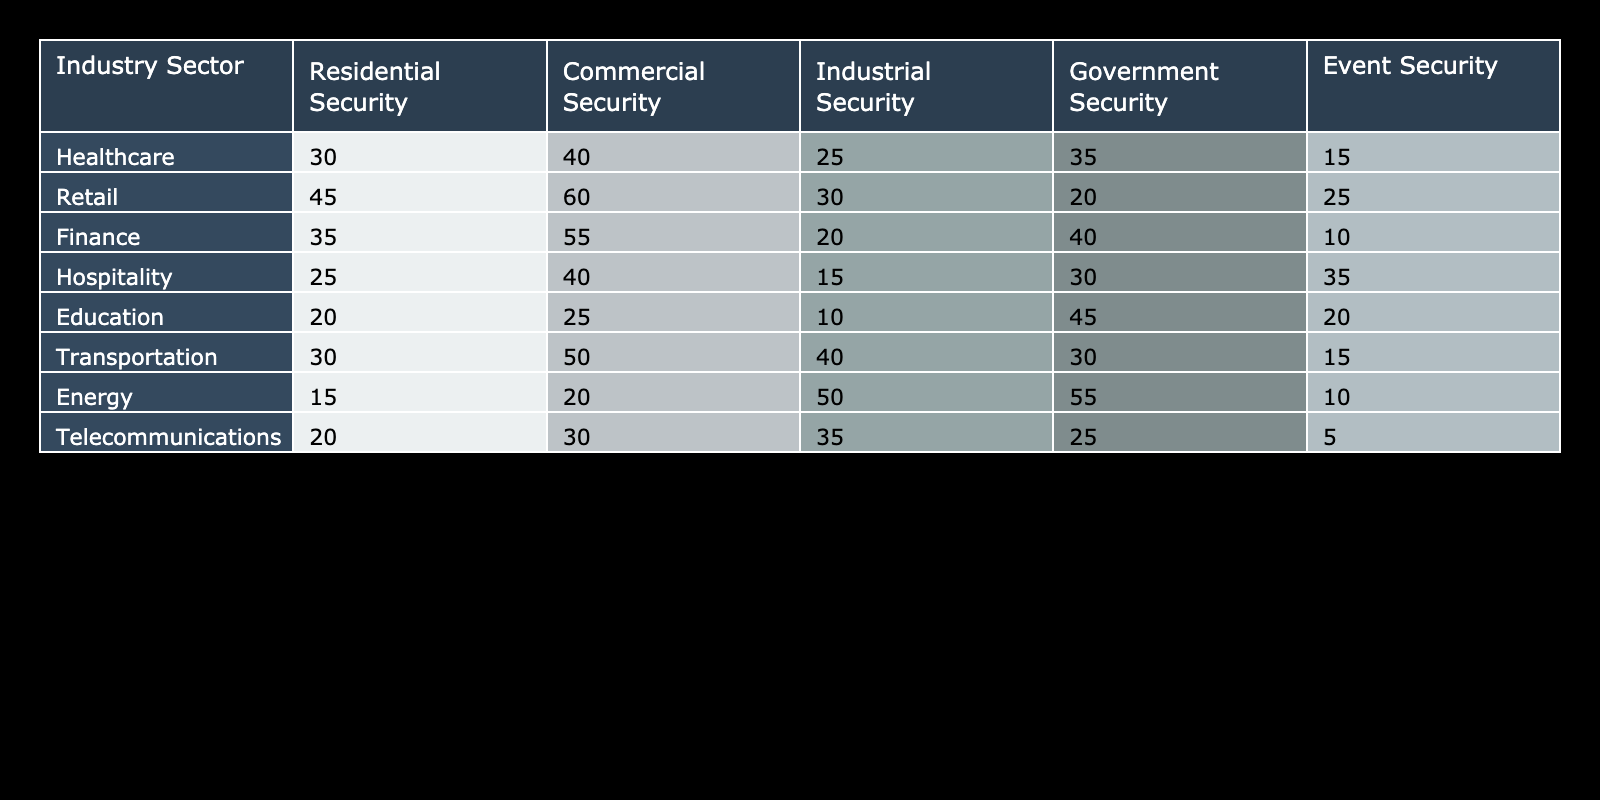What industry sector has the highest demand for commercial security services? By looking at the "Commercial Security" column across all the sectors, I see that "Retail" has the highest value of 60, which indicates that it has the highest demand for commercial security services among all sectors listed.
Answer: Retail What is the total demand for security services in the Education sector? To find the total demand in the Education sector, I add the values across all security types: 20 (Residential) + 25 (Commercial) + 10 (Industrial) + 45 (Government) + 20 (Event) = 120.
Answer: 120 Does the Energy sector have a higher demand for Industrial Security than the Telecommunications sector? Comparing the Industrial Security values, the Energy sector has 50, and the Telecommunications sector has 35. Since 50 is greater than 35, the statement is true.
Answer: Yes What is the average demand for Event Security across all sectors? To calculate the average, sum the Event Security values: 15 (Healthcare) + 25 (Retail) + 10 (Finance) + 35 (Hospitality) + 20 (Education) + 15 (Transportation) + 10 (Energy) + 5 (Telecommunications) = 135. Then divide by the number of sectors (8): 135 / 8 = 16.875.
Answer: 16.875 In which sector is the demand for Government Security the highest, and what is its value? Looking at the Government Security column, the highest value is 55, which is found in the Energy sector. Therefore, "Energy" is the sector with the highest demand for Government Security.
Answer: Energy, 55 